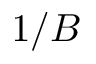<formula> <loc_0><loc_0><loc_500><loc_500>1 / B</formula> 